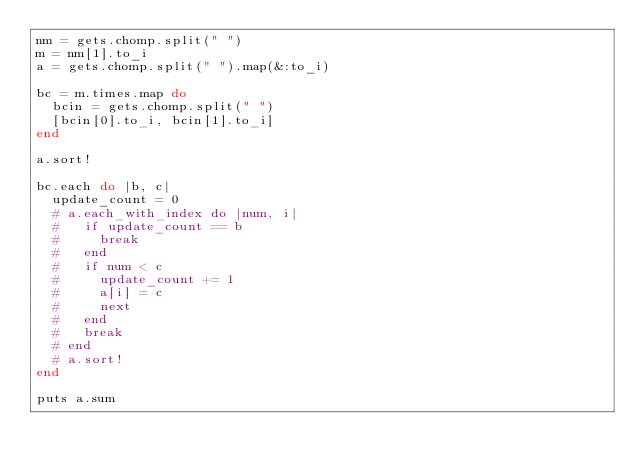Convert code to text. <code><loc_0><loc_0><loc_500><loc_500><_Ruby_>nm = gets.chomp.split(" ")
m = nm[1].to_i
a = gets.chomp.split(" ").map(&:to_i)

bc = m.times.map do
  bcin = gets.chomp.split(" ")
  [bcin[0].to_i, bcin[1].to_i]
end

a.sort!

bc.each do |b, c|
  update_count = 0
  # a.each_with_index do |num, i|
  #   if update_count == b
  #     break
  #   end
  #   if num < c
  #     update_count += 1
  #     a[i] = c
  #     next
  #   end
  #   break
  # end
  # a.sort!
end

puts a.sum
</code> 